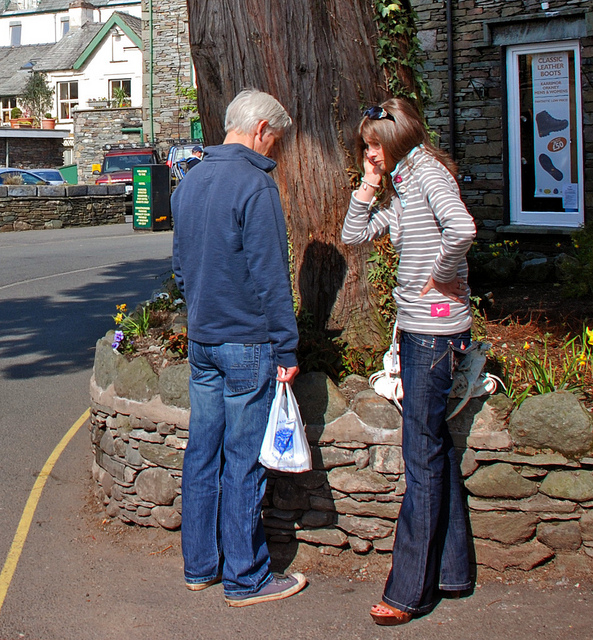Please transcribe the text information in this image. CLASSIC LOOTS 